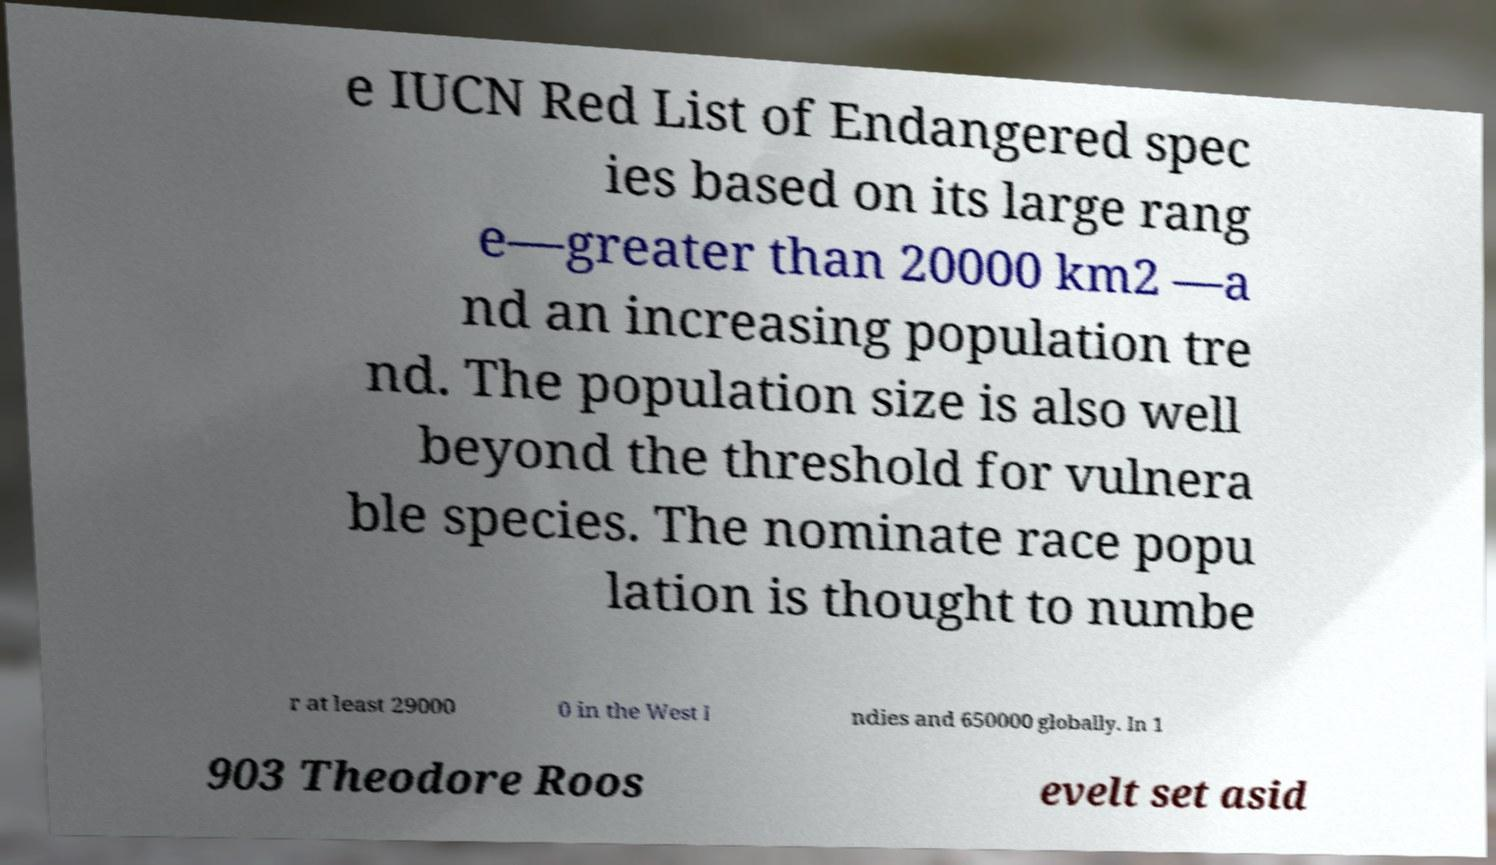Please read and relay the text visible in this image. What does it say? e IUCN Red List of Endangered spec ies based on its large rang e—greater than 20000 km2 —a nd an increasing population tre nd. The population size is also well beyond the threshold for vulnera ble species. The nominate race popu lation is thought to numbe r at least 29000 0 in the West I ndies and 650000 globally. In 1 903 Theodore Roos evelt set asid 